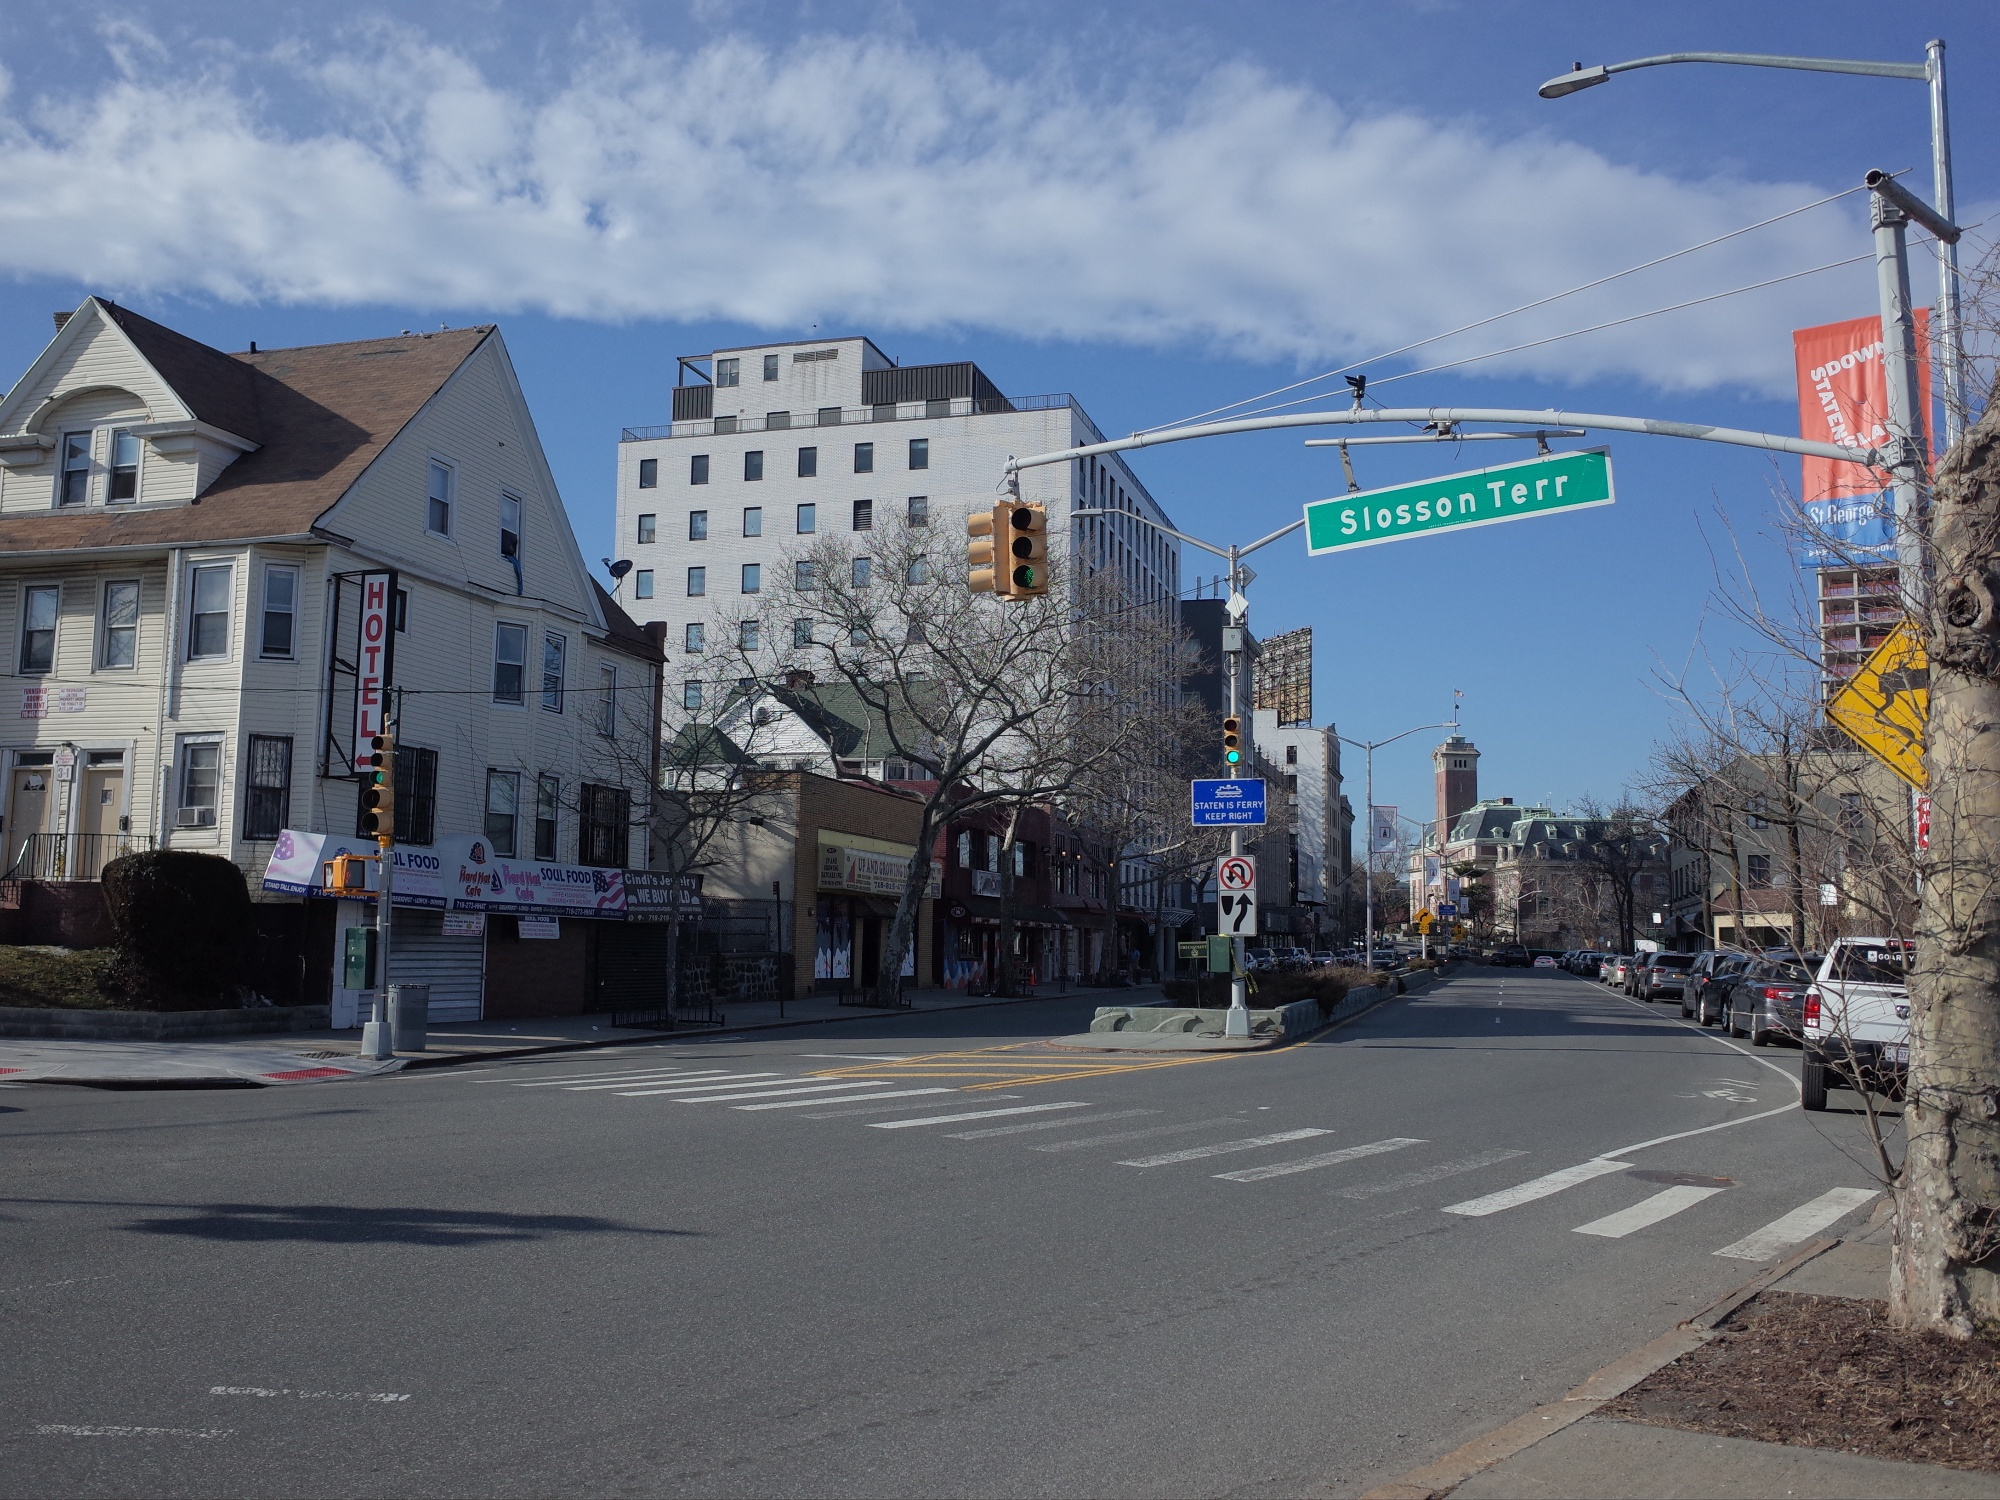Can you describe the ambiance of the image? The ambiance of the image is serene and calm. It's a quiet urban scene with no vehicles or people in sight, allowing the viewer to fully appreciate the blend of architectural styles and natural elements. The clear blue sky with a few scattered clouds enhances the peacefulness, and the gentle rustle of leaves from the trees lining the street can almost be imagined. The overall atmosphere is one of tranquility in a typically bustling city intersection. What can you say about the architectural styles visible in the image? The image showcases a variety of architectural styles, indicating a blend of different eras and influences. On the left, there is a charming, residential-style building with a pitched roof and an attached sign reading 'Hotel.' This building exudes a quaint, almost historical charm. In contrast, the white high-rise building in the background represents modern, minimalist architecture with its clean lines and simple facade. The street further down features more traditional designs with ornate facades, suggesting a more historical or classical influence in architecture. This mix creates a rich tapestry of urban landscape, highlighting the evolution of architectural design over time. What creative narration would you compose inspired by this scene? As the first light of dawn kissed the city, Slosson Terrace gently awakened. The tannish hotel, a keeper of countless stories, stood silently, its sign a beacon for weary travelers. Across from it, the white high-rise stretched towards the heavens, a symbol of modern ambition juxtaposed against its more historical neighbors. No cars nor people were yet to disturb the tranquility, allowing the trees to sway softly, whispering secrets to the clear blue sky. It was a moment where time seemed to stand still, an urban symphony of history, progress, and nature in perfect harmony. 